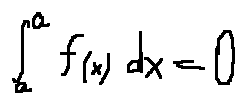<formula> <loc_0><loc_0><loc_500><loc_500>\int \lim i t s _ { a } ^ { a } f ( x ) d x = 0</formula> 